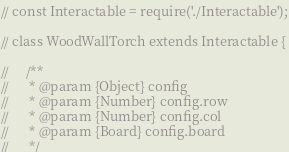Convert code to text. <code><loc_0><loc_0><loc_500><loc_500><_JavaScript_>// const Interactable = require('./Interactable');

// class WoodWallTorch extends Interactable {

//     /**
//      * @param {Object} config
//      * @param {Number} config.row
//      * @param {Number} config.col
//      * @param {Board} config.board
//      */</code> 